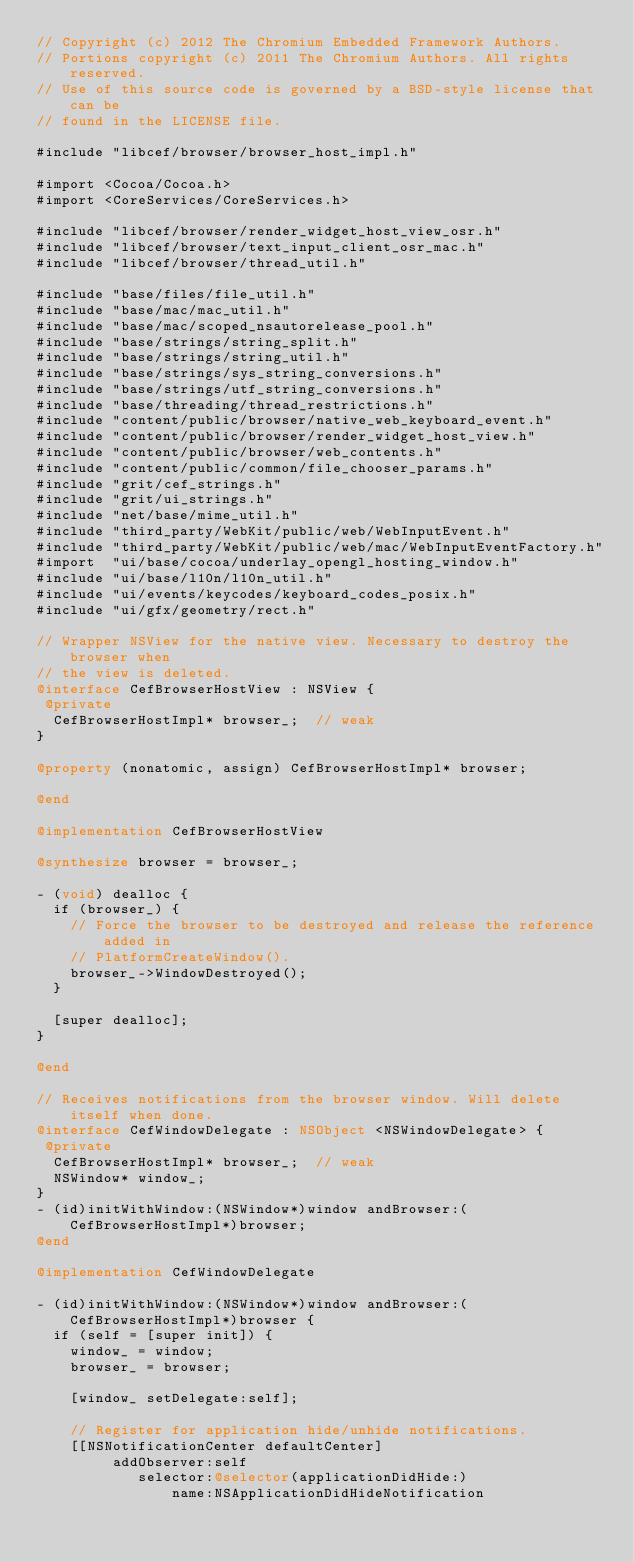<code> <loc_0><loc_0><loc_500><loc_500><_ObjectiveC_>// Copyright (c) 2012 The Chromium Embedded Framework Authors.
// Portions copyright (c) 2011 The Chromium Authors. All rights reserved.
// Use of this source code is governed by a BSD-style license that can be
// found in the LICENSE file.

#include "libcef/browser/browser_host_impl.h"

#import <Cocoa/Cocoa.h>
#import <CoreServices/CoreServices.h>

#include "libcef/browser/render_widget_host_view_osr.h"
#include "libcef/browser/text_input_client_osr_mac.h"
#include "libcef/browser/thread_util.h"

#include "base/files/file_util.h"
#include "base/mac/mac_util.h"
#include "base/mac/scoped_nsautorelease_pool.h"
#include "base/strings/string_split.h"
#include "base/strings/string_util.h"
#include "base/strings/sys_string_conversions.h"
#include "base/strings/utf_string_conversions.h"
#include "base/threading/thread_restrictions.h"
#include "content/public/browser/native_web_keyboard_event.h"
#include "content/public/browser/render_widget_host_view.h"
#include "content/public/browser/web_contents.h"
#include "content/public/common/file_chooser_params.h"
#include "grit/cef_strings.h"
#include "grit/ui_strings.h"
#include "net/base/mime_util.h"
#include "third_party/WebKit/public/web/WebInputEvent.h"
#include "third_party/WebKit/public/web/mac/WebInputEventFactory.h"
#import  "ui/base/cocoa/underlay_opengl_hosting_window.h"
#include "ui/base/l10n/l10n_util.h"
#include "ui/events/keycodes/keyboard_codes_posix.h"
#include "ui/gfx/geometry/rect.h"

// Wrapper NSView for the native view. Necessary to destroy the browser when
// the view is deleted.
@interface CefBrowserHostView : NSView {
 @private
  CefBrowserHostImpl* browser_;  // weak
}

@property (nonatomic, assign) CefBrowserHostImpl* browser;

@end

@implementation CefBrowserHostView

@synthesize browser = browser_;

- (void) dealloc {
  if (browser_) {
    // Force the browser to be destroyed and release the reference added in
    // PlatformCreateWindow().
    browser_->WindowDestroyed();
  }

  [super dealloc];
}

@end

// Receives notifications from the browser window. Will delete itself when done.
@interface CefWindowDelegate : NSObject <NSWindowDelegate> {
 @private
  CefBrowserHostImpl* browser_;  // weak
  NSWindow* window_;
}
- (id)initWithWindow:(NSWindow*)window andBrowser:(CefBrowserHostImpl*)browser;
@end

@implementation CefWindowDelegate

- (id)initWithWindow:(NSWindow*)window andBrowser:(CefBrowserHostImpl*)browser {
  if (self = [super init]) {
    window_ = window;
    browser_ = browser;

    [window_ setDelegate:self];

    // Register for application hide/unhide notifications.
    [[NSNotificationCenter defaultCenter]
         addObserver:self
            selector:@selector(applicationDidHide:)
                name:NSApplicationDidHideNotification</code> 